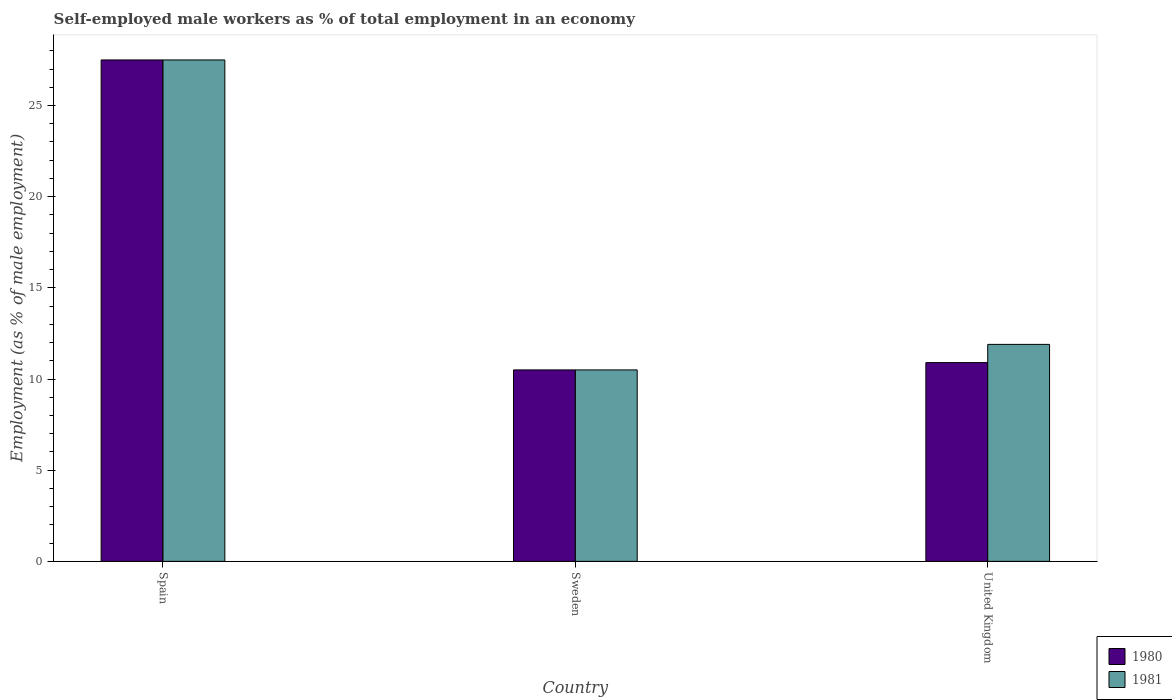How many different coloured bars are there?
Offer a very short reply. 2. How many groups of bars are there?
Make the answer very short. 3. Are the number of bars per tick equal to the number of legend labels?
Make the answer very short. Yes. How many bars are there on the 1st tick from the left?
Your response must be concise. 2. What is the percentage of self-employed male workers in 1980 in Spain?
Give a very brief answer. 27.5. What is the total percentage of self-employed male workers in 1981 in the graph?
Your answer should be compact. 49.9. What is the difference between the percentage of self-employed male workers in 1981 in Sweden and that in United Kingdom?
Your answer should be compact. -1.4. What is the difference between the percentage of self-employed male workers in 1981 in United Kingdom and the percentage of self-employed male workers in 1980 in Spain?
Make the answer very short. -15.6. What is the average percentage of self-employed male workers in 1980 per country?
Provide a short and direct response. 16.3. What is the difference between the percentage of self-employed male workers of/in 1981 and percentage of self-employed male workers of/in 1980 in Spain?
Offer a very short reply. 0. What is the ratio of the percentage of self-employed male workers in 1981 in Spain to that in Sweden?
Offer a very short reply. 2.62. What is the difference between the highest and the second highest percentage of self-employed male workers in 1981?
Give a very brief answer. 1.4. Is the sum of the percentage of self-employed male workers in 1980 in Spain and United Kingdom greater than the maximum percentage of self-employed male workers in 1981 across all countries?
Give a very brief answer. Yes. What does the 1st bar from the left in Sweden represents?
Keep it short and to the point. 1980. How many bars are there?
Your answer should be compact. 6. Are all the bars in the graph horizontal?
Your response must be concise. No. How many countries are there in the graph?
Offer a terse response. 3. Are the values on the major ticks of Y-axis written in scientific E-notation?
Keep it short and to the point. No. Does the graph contain grids?
Ensure brevity in your answer.  No. How are the legend labels stacked?
Keep it short and to the point. Vertical. What is the title of the graph?
Provide a succinct answer. Self-employed male workers as % of total employment in an economy. What is the label or title of the Y-axis?
Offer a very short reply. Employment (as % of male employment). What is the Employment (as % of male employment) in 1980 in United Kingdom?
Provide a short and direct response. 10.9. What is the Employment (as % of male employment) of 1981 in United Kingdom?
Your response must be concise. 11.9. Across all countries, what is the minimum Employment (as % of male employment) of 1980?
Your answer should be very brief. 10.5. Across all countries, what is the minimum Employment (as % of male employment) in 1981?
Keep it short and to the point. 10.5. What is the total Employment (as % of male employment) in 1980 in the graph?
Keep it short and to the point. 48.9. What is the total Employment (as % of male employment) in 1981 in the graph?
Provide a succinct answer. 49.9. What is the difference between the Employment (as % of male employment) of 1981 in Spain and that in Sweden?
Offer a terse response. 17. What is the difference between the Employment (as % of male employment) of 1980 in Spain and that in United Kingdom?
Offer a terse response. 16.6. What is the difference between the Employment (as % of male employment) of 1981 in Spain and that in United Kingdom?
Your answer should be compact. 15.6. What is the difference between the Employment (as % of male employment) of 1980 in Spain and the Employment (as % of male employment) of 1981 in United Kingdom?
Make the answer very short. 15.6. What is the difference between the Employment (as % of male employment) of 1980 in Sweden and the Employment (as % of male employment) of 1981 in United Kingdom?
Your response must be concise. -1.4. What is the average Employment (as % of male employment) of 1981 per country?
Make the answer very short. 16.63. What is the difference between the Employment (as % of male employment) in 1980 and Employment (as % of male employment) in 1981 in Spain?
Keep it short and to the point. 0. What is the difference between the Employment (as % of male employment) of 1980 and Employment (as % of male employment) of 1981 in United Kingdom?
Your answer should be very brief. -1. What is the ratio of the Employment (as % of male employment) of 1980 in Spain to that in Sweden?
Offer a very short reply. 2.62. What is the ratio of the Employment (as % of male employment) of 1981 in Spain to that in Sweden?
Give a very brief answer. 2.62. What is the ratio of the Employment (as % of male employment) of 1980 in Spain to that in United Kingdom?
Offer a terse response. 2.52. What is the ratio of the Employment (as % of male employment) in 1981 in Spain to that in United Kingdom?
Keep it short and to the point. 2.31. What is the ratio of the Employment (as % of male employment) of 1980 in Sweden to that in United Kingdom?
Offer a terse response. 0.96. What is the ratio of the Employment (as % of male employment) in 1981 in Sweden to that in United Kingdom?
Give a very brief answer. 0.88. What is the difference between the highest and the second highest Employment (as % of male employment) of 1980?
Provide a short and direct response. 16.6. What is the difference between the highest and the lowest Employment (as % of male employment) in 1980?
Make the answer very short. 17. What is the difference between the highest and the lowest Employment (as % of male employment) in 1981?
Your answer should be very brief. 17. 